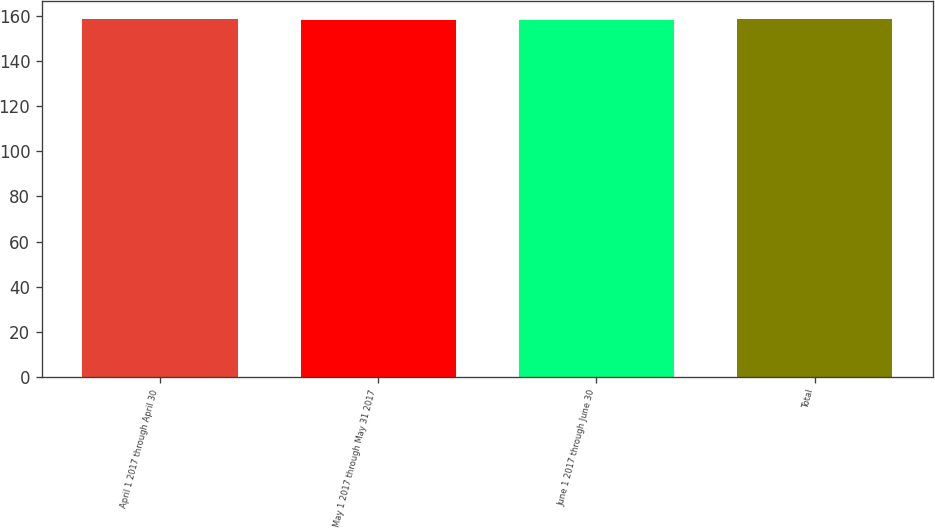Convert chart. <chart><loc_0><loc_0><loc_500><loc_500><bar_chart><fcel>April 1 2017 through April 30<fcel>May 1 2017 through May 31 2017<fcel>June 1 2017 through June 30<fcel>Total<nl><fcel>158.85<fcel>158.39<fcel>158.44<fcel>158.55<nl></chart> 